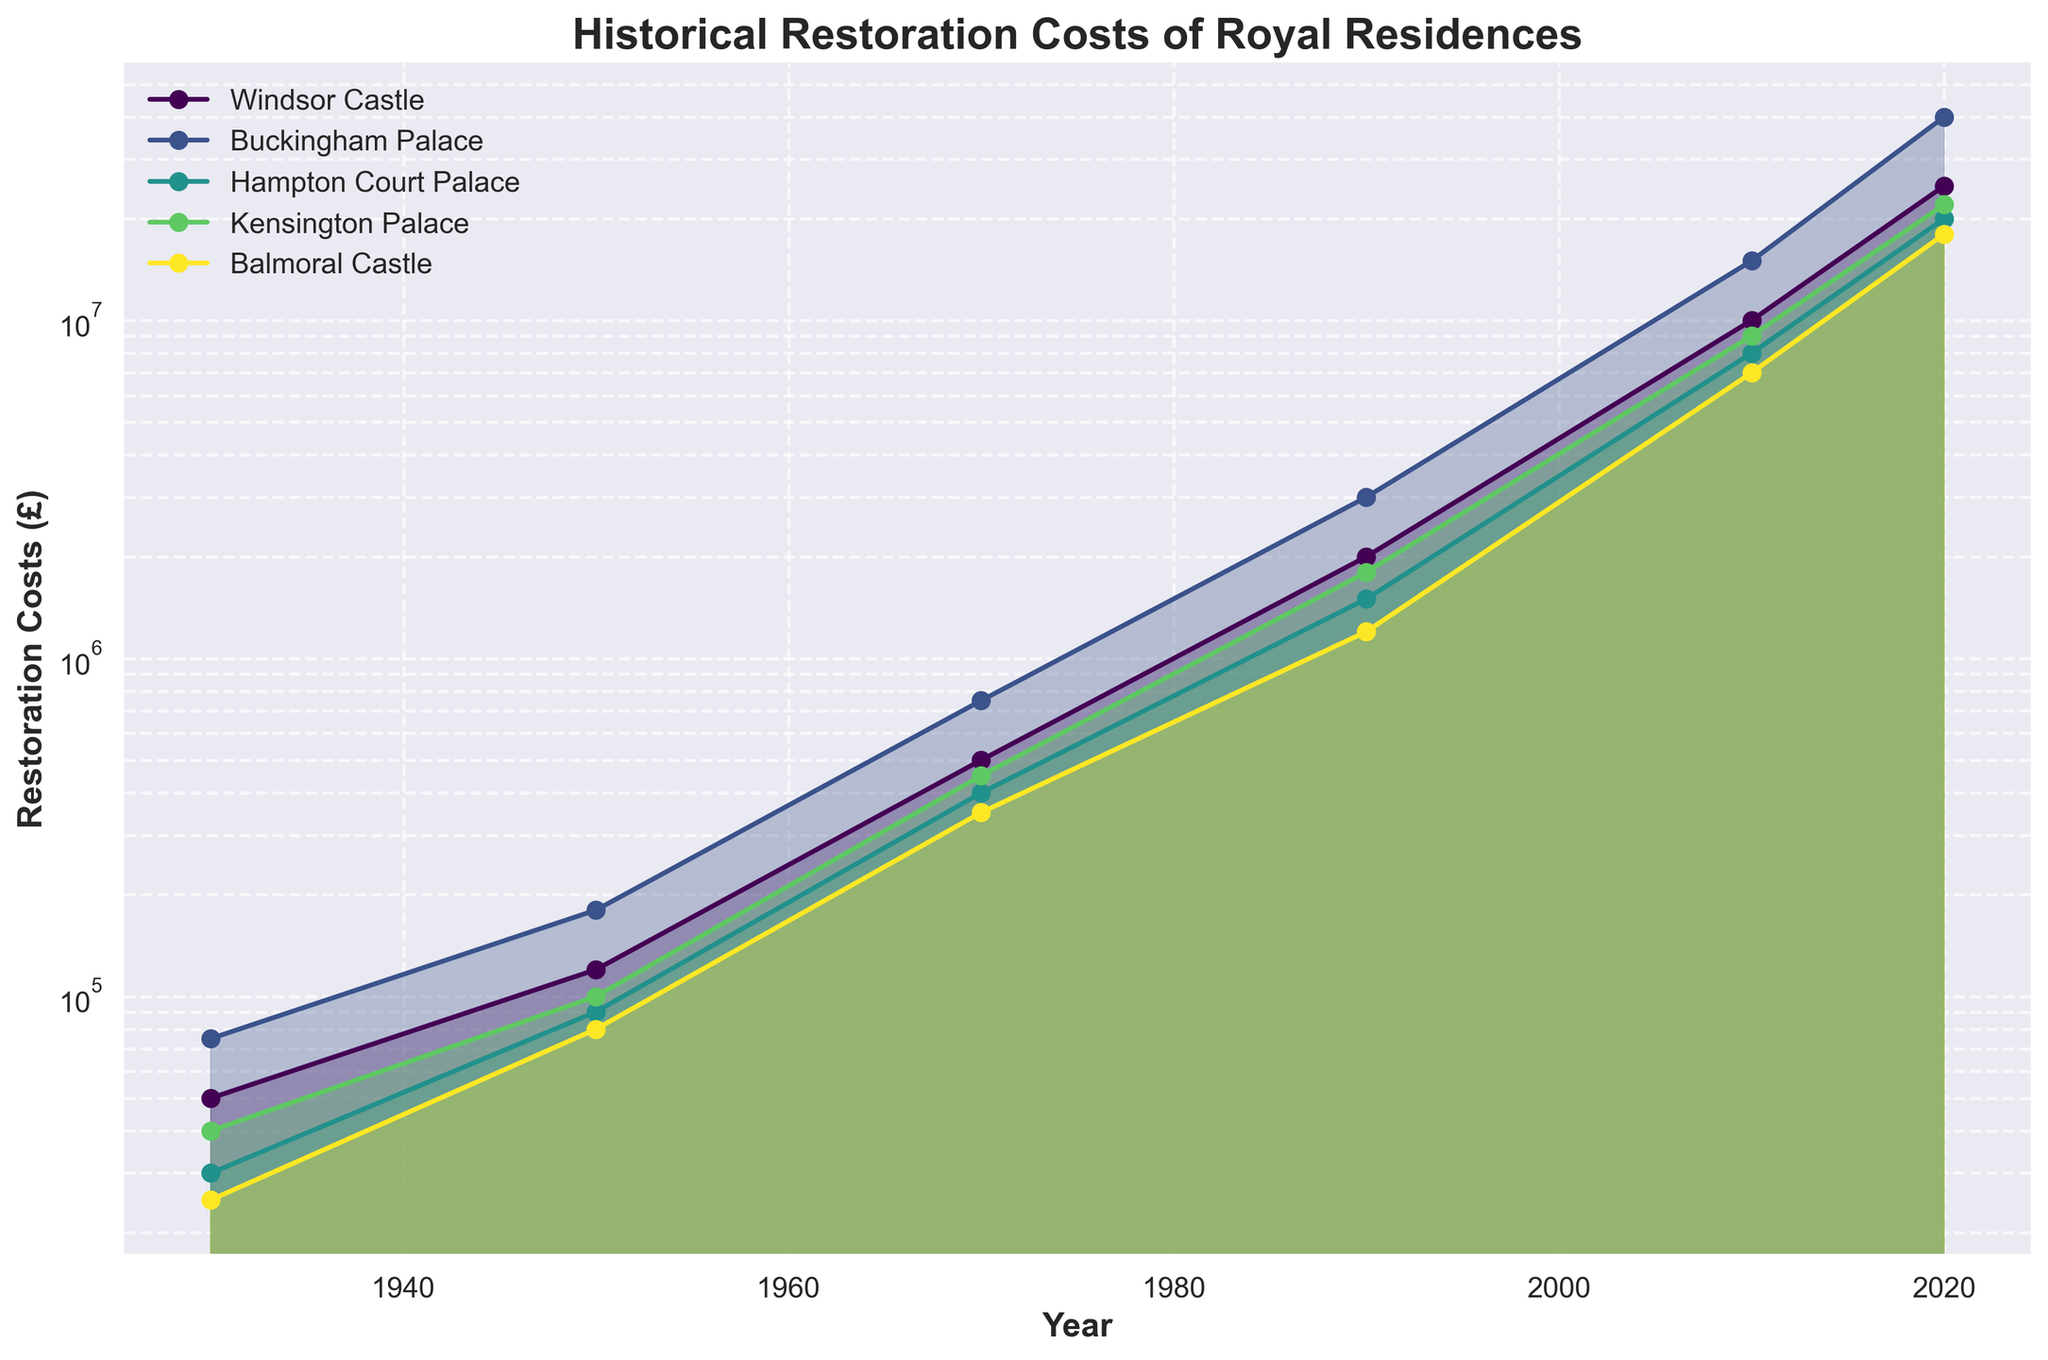What's the title of the figure? The title is located at the top-center of the figure, clearly stating its purpose.
Answer: Historical Restoration Costs of Royal Residences Which royal residence had the highest restoration cost in 2020? By locating the year 2020 on the x-axis and identifying the highest point among the series, the most elevated line corresponds to Buckingham Palace.
Answer: Buckingham Palace What is the scale used for the y-axis? The y-axis uses a log scale, which is evident by the non-linear spacing of the values.
Answer: Logarithmic scale What is the restoration cost for Windsor Castle in 1950? Find the year 1950 on the x-axis and trace the line representing Windsor Castle to its value on the y-axis, which is 120,000.
Answer: £120,000 What was the difference in restoration costs between Hampton Court Palace and Balmoral Castle in 2010? Identify the costs for both in 2010: Hampton Court Palace at 8,000,000 and Balmoral Castle at 7,000,000. The difference is 1,000,000.
Answer: £1,000,000 Which residence experienced the highest restoration cost increase between 1930 and 2020? Compare the starting and ending values of each residence. Buckingham Palace's increase from 75,000 to 40,000,000 is the highest.
Answer: Buckingham Palace Did Kensington Palace ever surpass Hampton Court Palace in restoration costs during the period shown? Check if the purple line for Kensington Palace ever crosses below the yellow line for Hampton Court Palace between 1930 and 2020. It does not.
Answer: No How many residences had a restoration cost greater than £1,000,000 in 1990? Look at the year 1990 on the x-axis. All five lines (Windsor Castle, Buckingham Palace, Hampton Court Palace, Kensington Palace, Balmoral Castle) indicate costs greater than £1,000,000.
Answer: Five What is the average restoration cost for Windsor Castle over the recorded years? Sum Windsor Castle's costs (50,000 + 120,000 + 500,000 + 2,000,000 + 10,000,000 + 25,000,000) = 37,670,000 and divide by 6.
Answer: £6,278,333 Which residence had the least average increase in restoration costs per decade? Calculate the increase per decade for each. Windsor Castle: 2495000, Buckingham Palace: 3990833, Hampton Court Palace: 1991667, Kensington Palace: 2231667, Balmoral Castle: 1816667. Balmoral Castle has the least average increase.
Answer: Balmoral Castle 